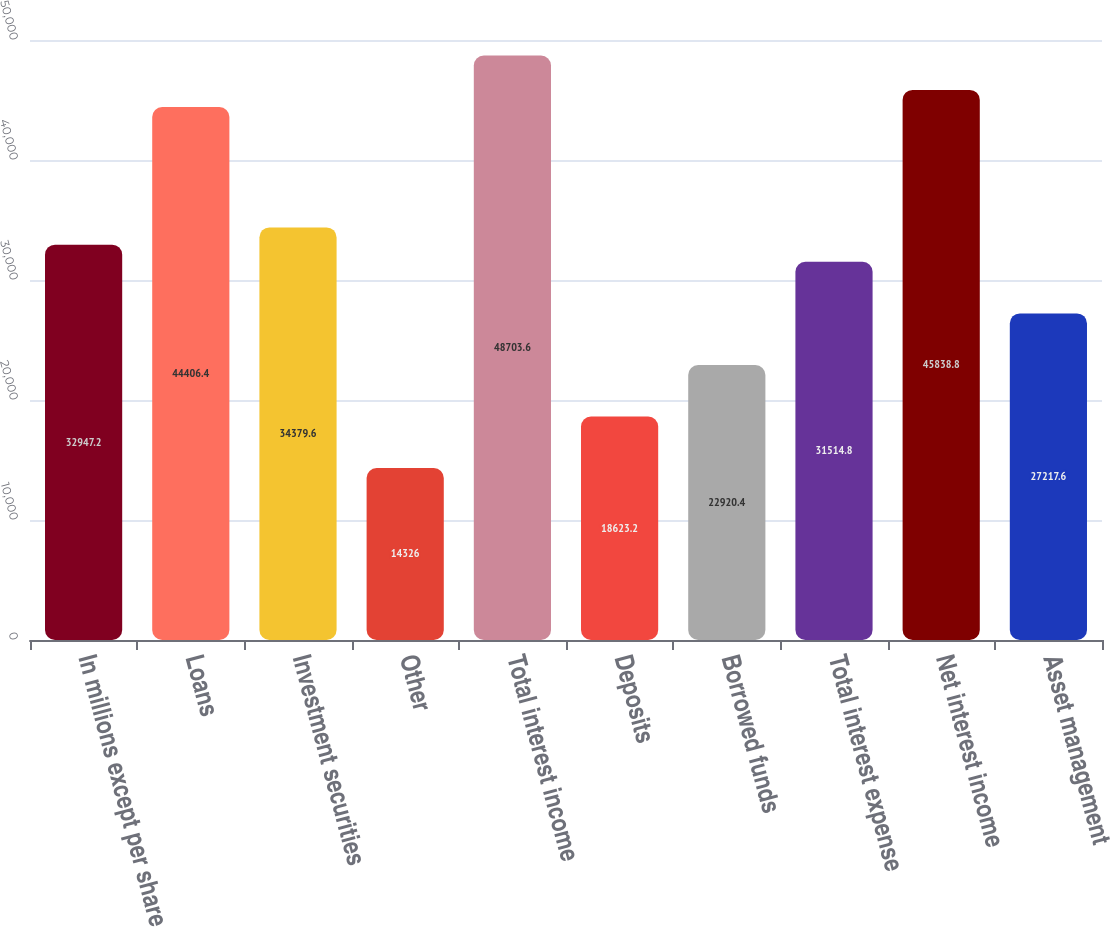<chart> <loc_0><loc_0><loc_500><loc_500><bar_chart><fcel>In millions except per share<fcel>Loans<fcel>Investment securities<fcel>Other<fcel>Total interest income<fcel>Deposits<fcel>Borrowed funds<fcel>Total interest expense<fcel>Net interest income<fcel>Asset management<nl><fcel>32947.2<fcel>44406.4<fcel>34379.6<fcel>14326<fcel>48703.6<fcel>18623.2<fcel>22920.4<fcel>31514.8<fcel>45838.8<fcel>27217.6<nl></chart> 